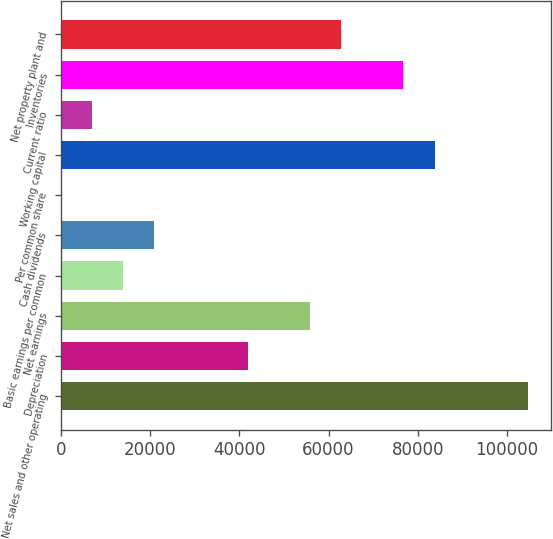<chart> <loc_0><loc_0><loc_500><loc_500><bar_chart><fcel>Net sales and other operating<fcel>Depreciation<fcel>Net earnings<fcel>Basic earnings per common<fcel>Cash dividends<fcel>Per common share<fcel>Working capital<fcel>Current ratio<fcel>Inventories<fcel>Net property plant and<nl><fcel>104724<fcel>41889.8<fcel>55852.9<fcel>13963.6<fcel>20945.1<fcel>0.49<fcel>83779.1<fcel>6982.04<fcel>76797.5<fcel>62834.4<nl></chart> 